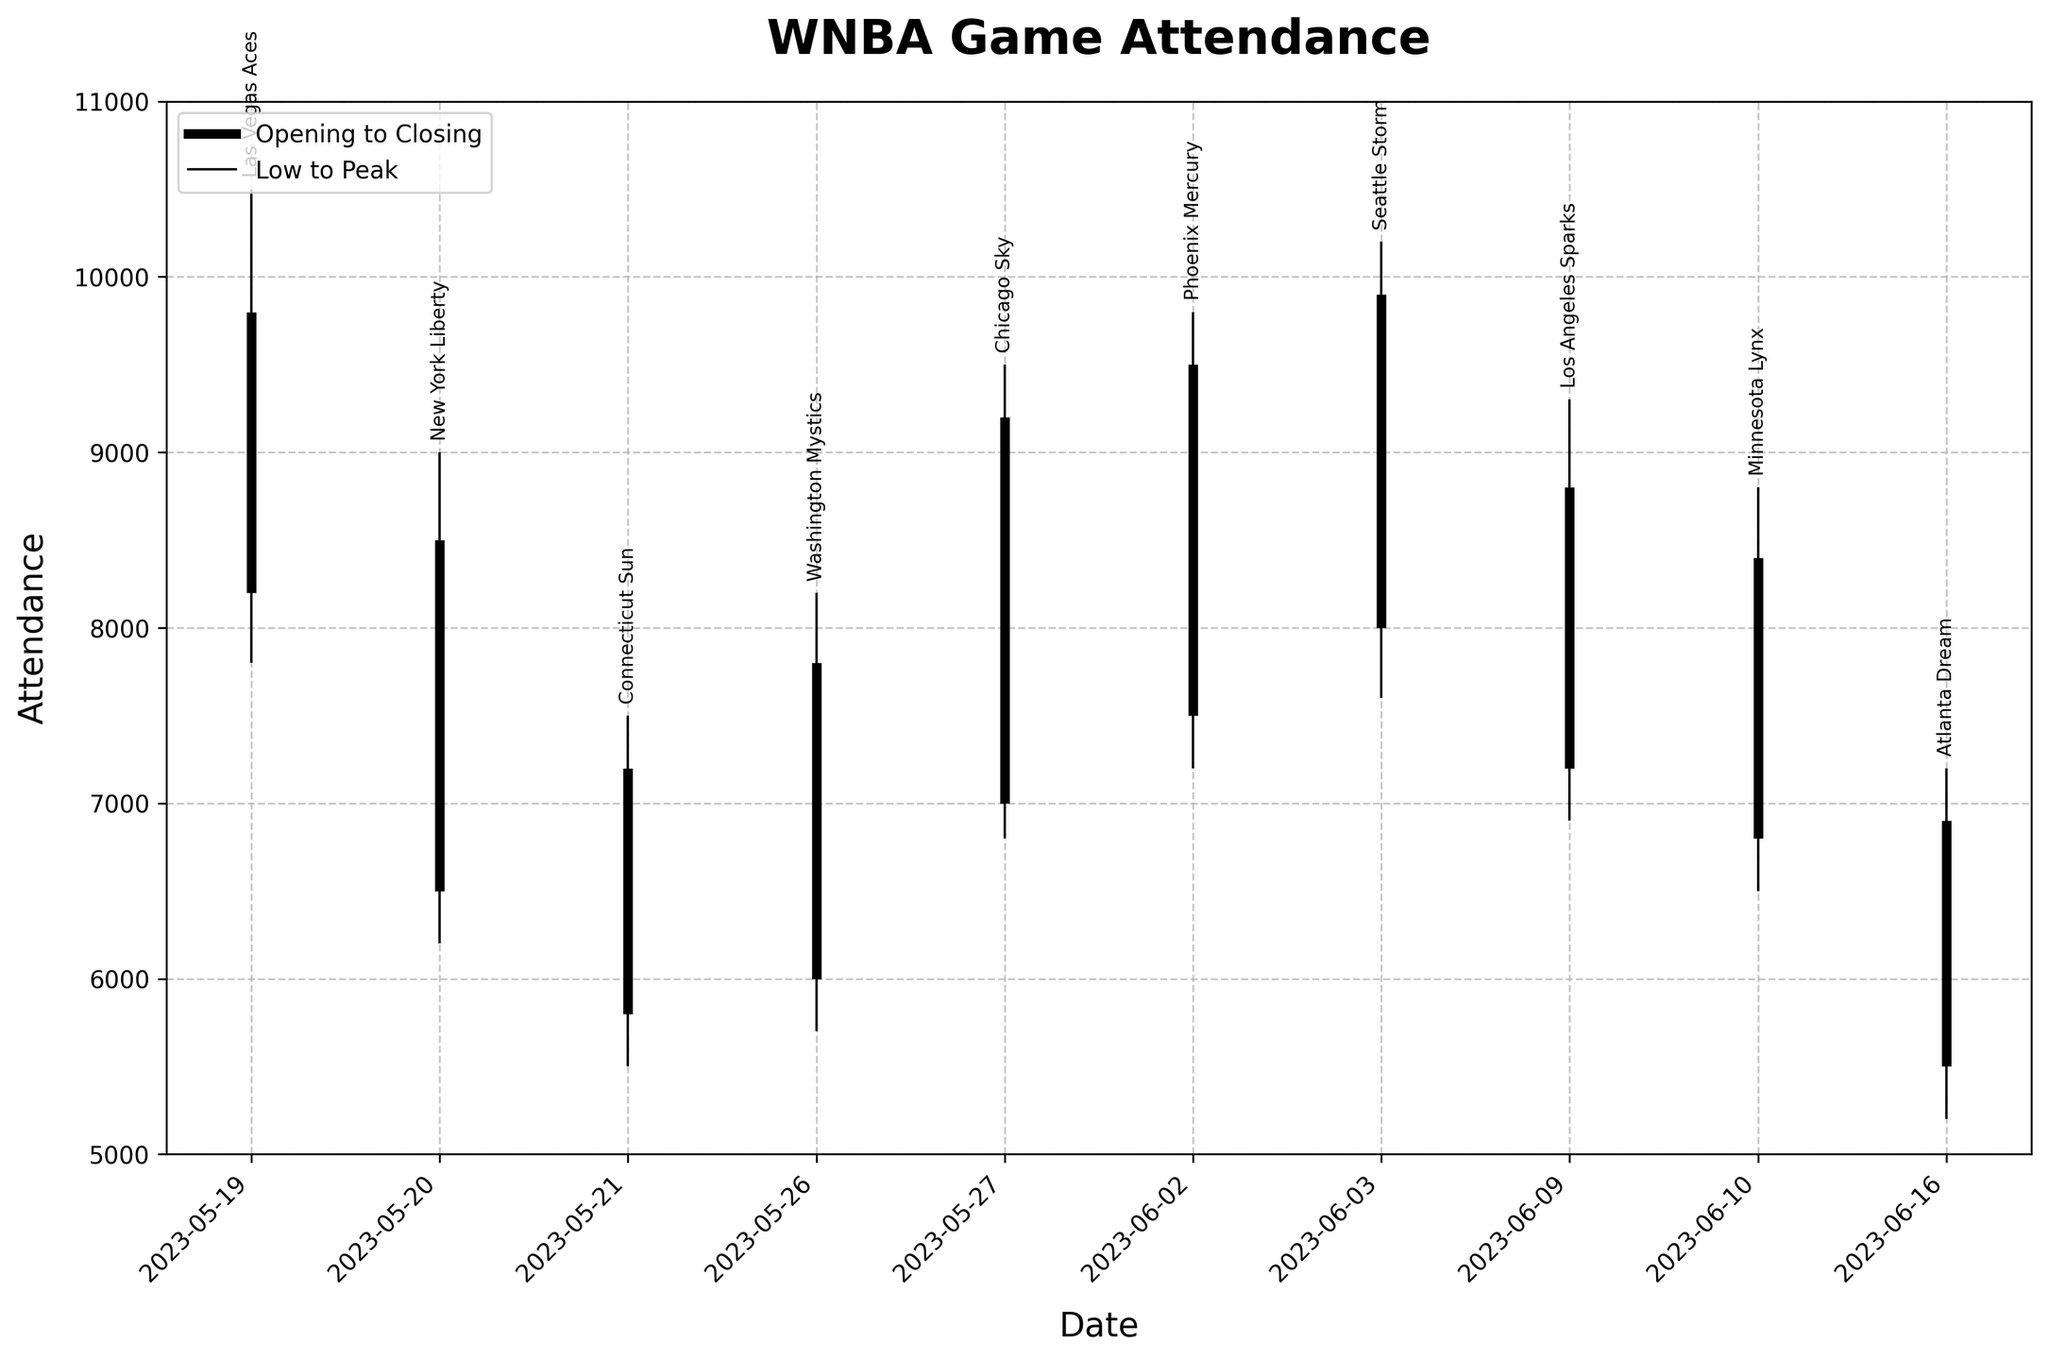What is the title of the chart? The title of the chart is written at the top of the figure. It is bold and prominent.
Answer: WNBA Game Attendance How many data points are displayed in the chart? The chart has vertical lines representing each game day, with individual data points for each team indicated on different game dates. By counting these lines, we ascertain the data points.
Answer: 10 Which game had the highest peak attendance? The peak attendance is represented by the top of the blackout lines for each game. The label beside the highest mark indicates the team for that game.
Answer: Seattle Storm on 2023-06-03 What was the range of attendance for the Las Vegas Aces game on 2023-05-19? The range is the difference between the peak and low attendance values. For the Las Vegas Aces game, the peak attendance was 10500 and the low was 7800. Subtracting these gives the range.
Answer: 2700 What is the average closing attendance across all games? To find the average closing attendance, sum all the closing attendances and divide by the number of games. The closing values are: 9800, 8500, 7200, 7800, 9200, 9500, 9900, 8800, 8400, 6900. Adding these gives 86000, and dividing by 10 gives the average.
Answer: 8600 Which team had the lowest opening attendance and what was that figure? The opening attendance figures are shown at the start of the thick black lines. Identifying the lowest value among them and the corresponding team will give the answer.
Answer: Atlanta Dream with 5500 Compare the attendance of the New York Liberty game on 2023-05-20 to that of the Washington Mystics game on 2023-05-26. Which game had a higher low attendance? Examine the low attendance figures for both games marked by the bottom of the blackout lines. Compare these values directly.
Answer: New York Liberty with 6200 What is the attendance change for the Phoenix Mercury game from opening to closing? The change in attendance is found by subtracting the opening value from the closing value of the same game. For the Phoenix Mercury game: 9500 (closing) - 7500 (opening).
Answer: 2000 Identify the game with the smallest range of attendance. Range is determined by subtracting the low attendance from the peak attendance for each game. The game with the smallest value after this subtraction is the answer.
Answer: Atlanta Dream on 2023-06-16 Which game had its closing attendance closest to its peak attendance? For this, calculate the difference between closing and peak attendances for each game. The game with the smallest difference is the answer.
Answer: Seattle Storm on 2023-06-03 